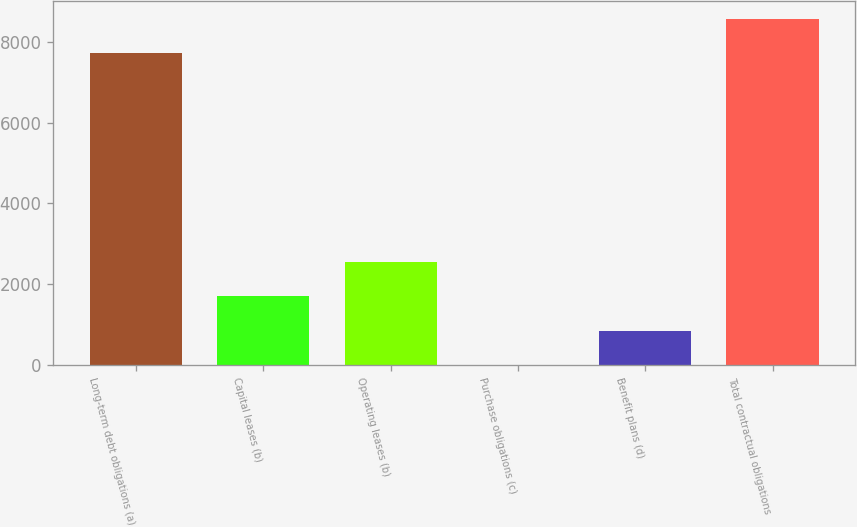Convert chart to OTSL. <chart><loc_0><loc_0><loc_500><loc_500><bar_chart><fcel>Long-term debt obligations (a)<fcel>Capital leases (b)<fcel>Operating leases (b)<fcel>Purchase obligations (c)<fcel>Benefit plans (d)<fcel>Total contractual obligations<nl><fcel>7733<fcel>1695.4<fcel>2542.6<fcel>1<fcel>848.2<fcel>8580.2<nl></chart> 